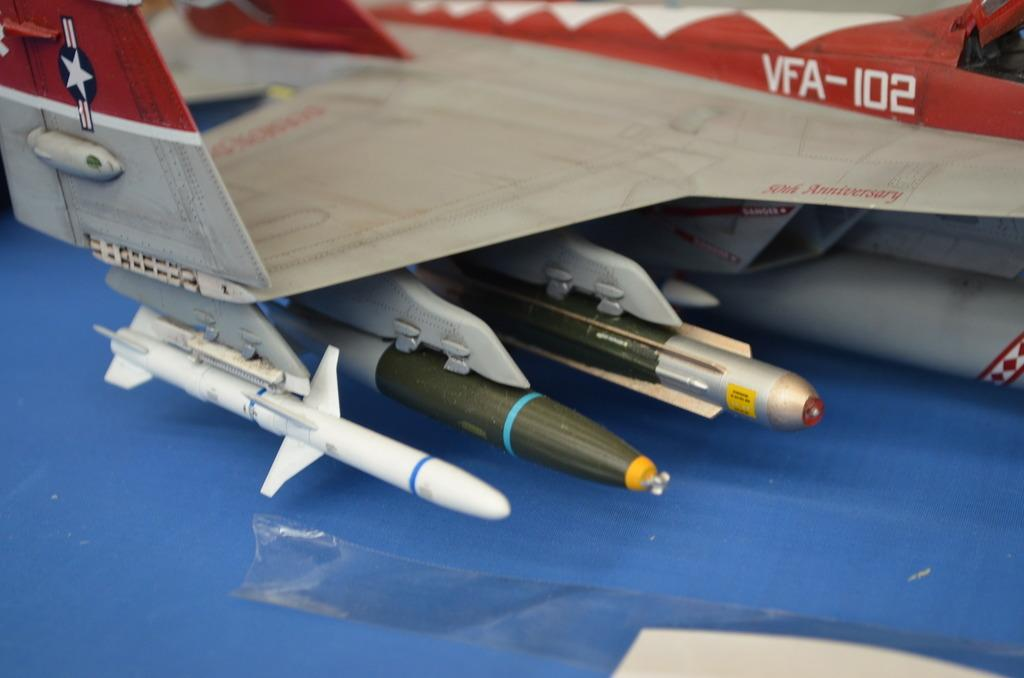What type of toy is in the image? There is a toy jet in the image. How much of the toy jet can be seen? The toy jet is partially visible in the image. What is located at the bottom of the image? There is a plaster at the bottom of the image. How does the kitten adjust the toy jet in the image? There is no kitten present in the image, so it cannot adjust the toy jet. 